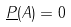Convert formula to latex. <formula><loc_0><loc_0><loc_500><loc_500>\underline { P } ( A ) = 0</formula> 